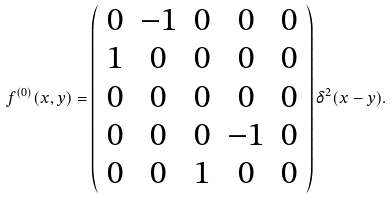Convert formula to latex. <formula><loc_0><loc_0><loc_500><loc_500>f ^ { ( 0 ) } ( x , y ) = \left ( \begin{array} { c c c c c } 0 & - 1 & 0 & 0 & 0 \\ 1 & 0 & 0 & 0 & 0 \\ 0 & 0 & 0 & 0 & 0 \\ 0 & 0 & 0 & - 1 & 0 \\ 0 & 0 & 1 & 0 & 0 \end{array} \right ) \delta ^ { 2 } ( x - y ) .</formula> 